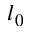<formula> <loc_0><loc_0><loc_500><loc_500>l _ { 0 }</formula> 